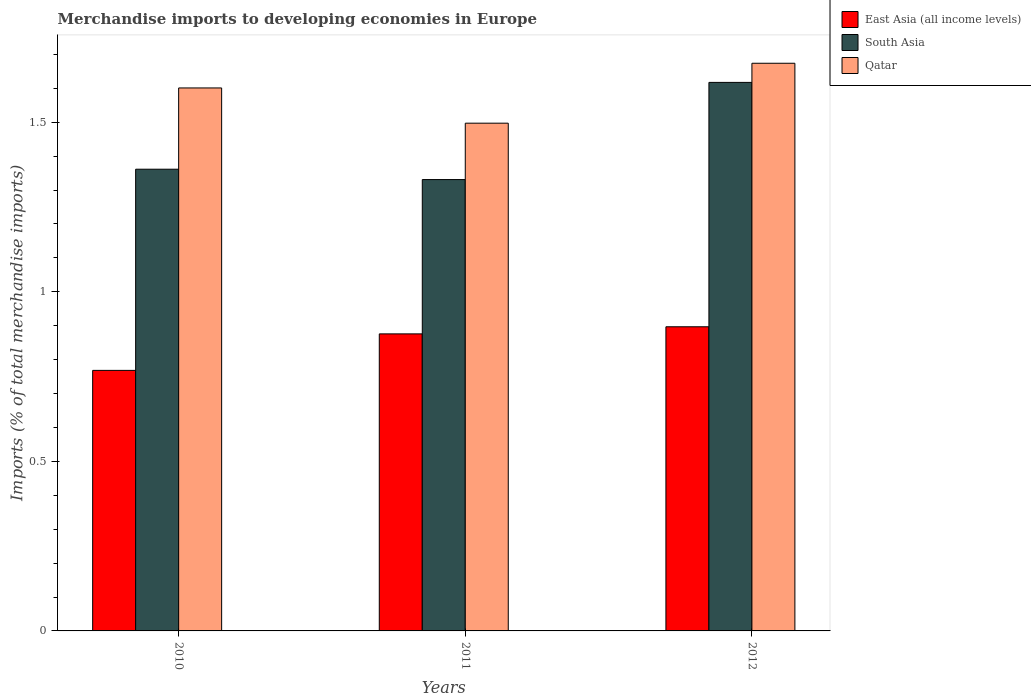How many different coloured bars are there?
Your answer should be compact. 3. Are the number of bars on each tick of the X-axis equal?
Your answer should be compact. Yes. How many bars are there on the 3rd tick from the right?
Provide a succinct answer. 3. What is the label of the 2nd group of bars from the left?
Offer a very short reply. 2011. What is the percentage total merchandise imports in East Asia (all income levels) in 2010?
Provide a short and direct response. 0.77. Across all years, what is the maximum percentage total merchandise imports in Qatar?
Make the answer very short. 1.67. Across all years, what is the minimum percentage total merchandise imports in Qatar?
Keep it short and to the point. 1.5. What is the total percentage total merchandise imports in Qatar in the graph?
Make the answer very short. 4.77. What is the difference between the percentage total merchandise imports in South Asia in 2011 and that in 2012?
Keep it short and to the point. -0.29. What is the difference between the percentage total merchandise imports in South Asia in 2011 and the percentage total merchandise imports in East Asia (all income levels) in 2012?
Make the answer very short. 0.43. What is the average percentage total merchandise imports in South Asia per year?
Make the answer very short. 1.44. In the year 2012, what is the difference between the percentage total merchandise imports in East Asia (all income levels) and percentage total merchandise imports in South Asia?
Make the answer very short. -0.72. What is the ratio of the percentage total merchandise imports in South Asia in 2010 to that in 2012?
Offer a terse response. 0.84. What is the difference between the highest and the second highest percentage total merchandise imports in Qatar?
Your response must be concise. 0.07. What is the difference between the highest and the lowest percentage total merchandise imports in South Asia?
Offer a terse response. 0.29. What does the 3rd bar from the left in 2010 represents?
Ensure brevity in your answer.  Qatar. Are the values on the major ticks of Y-axis written in scientific E-notation?
Give a very brief answer. No. Does the graph contain any zero values?
Your answer should be compact. No. Where does the legend appear in the graph?
Keep it short and to the point. Top right. How are the legend labels stacked?
Offer a very short reply. Vertical. What is the title of the graph?
Offer a very short reply. Merchandise imports to developing economies in Europe. Does "Lower middle income" appear as one of the legend labels in the graph?
Provide a short and direct response. No. What is the label or title of the X-axis?
Keep it short and to the point. Years. What is the label or title of the Y-axis?
Your response must be concise. Imports (% of total merchandise imports). What is the Imports (% of total merchandise imports) of East Asia (all income levels) in 2010?
Offer a very short reply. 0.77. What is the Imports (% of total merchandise imports) of South Asia in 2010?
Offer a terse response. 1.36. What is the Imports (% of total merchandise imports) in Qatar in 2010?
Provide a succinct answer. 1.6. What is the Imports (% of total merchandise imports) of East Asia (all income levels) in 2011?
Your response must be concise. 0.88. What is the Imports (% of total merchandise imports) in South Asia in 2011?
Offer a terse response. 1.33. What is the Imports (% of total merchandise imports) of Qatar in 2011?
Your response must be concise. 1.5. What is the Imports (% of total merchandise imports) in East Asia (all income levels) in 2012?
Offer a very short reply. 0.9. What is the Imports (% of total merchandise imports) in South Asia in 2012?
Keep it short and to the point. 1.62. What is the Imports (% of total merchandise imports) in Qatar in 2012?
Give a very brief answer. 1.67. Across all years, what is the maximum Imports (% of total merchandise imports) in East Asia (all income levels)?
Give a very brief answer. 0.9. Across all years, what is the maximum Imports (% of total merchandise imports) of South Asia?
Provide a short and direct response. 1.62. Across all years, what is the maximum Imports (% of total merchandise imports) in Qatar?
Provide a short and direct response. 1.67. Across all years, what is the minimum Imports (% of total merchandise imports) in East Asia (all income levels)?
Offer a very short reply. 0.77. Across all years, what is the minimum Imports (% of total merchandise imports) in South Asia?
Give a very brief answer. 1.33. Across all years, what is the minimum Imports (% of total merchandise imports) of Qatar?
Ensure brevity in your answer.  1.5. What is the total Imports (% of total merchandise imports) in East Asia (all income levels) in the graph?
Your answer should be very brief. 2.54. What is the total Imports (% of total merchandise imports) in South Asia in the graph?
Provide a short and direct response. 4.31. What is the total Imports (% of total merchandise imports) of Qatar in the graph?
Make the answer very short. 4.77. What is the difference between the Imports (% of total merchandise imports) of East Asia (all income levels) in 2010 and that in 2011?
Offer a very short reply. -0.11. What is the difference between the Imports (% of total merchandise imports) in South Asia in 2010 and that in 2011?
Make the answer very short. 0.03. What is the difference between the Imports (% of total merchandise imports) of Qatar in 2010 and that in 2011?
Offer a terse response. 0.1. What is the difference between the Imports (% of total merchandise imports) of East Asia (all income levels) in 2010 and that in 2012?
Your response must be concise. -0.13. What is the difference between the Imports (% of total merchandise imports) in South Asia in 2010 and that in 2012?
Your response must be concise. -0.26. What is the difference between the Imports (% of total merchandise imports) in Qatar in 2010 and that in 2012?
Offer a very short reply. -0.07. What is the difference between the Imports (% of total merchandise imports) of East Asia (all income levels) in 2011 and that in 2012?
Give a very brief answer. -0.02. What is the difference between the Imports (% of total merchandise imports) in South Asia in 2011 and that in 2012?
Your answer should be very brief. -0.29. What is the difference between the Imports (% of total merchandise imports) of Qatar in 2011 and that in 2012?
Ensure brevity in your answer.  -0.18. What is the difference between the Imports (% of total merchandise imports) of East Asia (all income levels) in 2010 and the Imports (% of total merchandise imports) of South Asia in 2011?
Offer a terse response. -0.56. What is the difference between the Imports (% of total merchandise imports) of East Asia (all income levels) in 2010 and the Imports (% of total merchandise imports) of Qatar in 2011?
Offer a terse response. -0.73. What is the difference between the Imports (% of total merchandise imports) of South Asia in 2010 and the Imports (% of total merchandise imports) of Qatar in 2011?
Give a very brief answer. -0.14. What is the difference between the Imports (% of total merchandise imports) in East Asia (all income levels) in 2010 and the Imports (% of total merchandise imports) in South Asia in 2012?
Offer a terse response. -0.85. What is the difference between the Imports (% of total merchandise imports) in East Asia (all income levels) in 2010 and the Imports (% of total merchandise imports) in Qatar in 2012?
Ensure brevity in your answer.  -0.91. What is the difference between the Imports (% of total merchandise imports) in South Asia in 2010 and the Imports (% of total merchandise imports) in Qatar in 2012?
Provide a short and direct response. -0.31. What is the difference between the Imports (% of total merchandise imports) of East Asia (all income levels) in 2011 and the Imports (% of total merchandise imports) of South Asia in 2012?
Your answer should be very brief. -0.74. What is the difference between the Imports (% of total merchandise imports) in East Asia (all income levels) in 2011 and the Imports (% of total merchandise imports) in Qatar in 2012?
Your answer should be compact. -0.8. What is the difference between the Imports (% of total merchandise imports) in South Asia in 2011 and the Imports (% of total merchandise imports) in Qatar in 2012?
Your answer should be compact. -0.34. What is the average Imports (% of total merchandise imports) in East Asia (all income levels) per year?
Make the answer very short. 0.85. What is the average Imports (% of total merchandise imports) of South Asia per year?
Provide a short and direct response. 1.44. What is the average Imports (% of total merchandise imports) in Qatar per year?
Provide a succinct answer. 1.59. In the year 2010, what is the difference between the Imports (% of total merchandise imports) of East Asia (all income levels) and Imports (% of total merchandise imports) of South Asia?
Your response must be concise. -0.59. In the year 2010, what is the difference between the Imports (% of total merchandise imports) of East Asia (all income levels) and Imports (% of total merchandise imports) of Qatar?
Your answer should be compact. -0.83. In the year 2010, what is the difference between the Imports (% of total merchandise imports) of South Asia and Imports (% of total merchandise imports) of Qatar?
Offer a terse response. -0.24. In the year 2011, what is the difference between the Imports (% of total merchandise imports) in East Asia (all income levels) and Imports (% of total merchandise imports) in South Asia?
Provide a short and direct response. -0.46. In the year 2011, what is the difference between the Imports (% of total merchandise imports) of East Asia (all income levels) and Imports (% of total merchandise imports) of Qatar?
Offer a terse response. -0.62. In the year 2011, what is the difference between the Imports (% of total merchandise imports) of South Asia and Imports (% of total merchandise imports) of Qatar?
Provide a short and direct response. -0.17. In the year 2012, what is the difference between the Imports (% of total merchandise imports) of East Asia (all income levels) and Imports (% of total merchandise imports) of South Asia?
Provide a short and direct response. -0.72. In the year 2012, what is the difference between the Imports (% of total merchandise imports) in East Asia (all income levels) and Imports (% of total merchandise imports) in Qatar?
Provide a succinct answer. -0.78. In the year 2012, what is the difference between the Imports (% of total merchandise imports) in South Asia and Imports (% of total merchandise imports) in Qatar?
Offer a terse response. -0.06. What is the ratio of the Imports (% of total merchandise imports) in East Asia (all income levels) in 2010 to that in 2011?
Your answer should be compact. 0.88. What is the ratio of the Imports (% of total merchandise imports) of Qatar in 2010 to that in 2011?
Provide a succinct answer. 1.07. What is the ratio of the Imports (% of total merchandise imports) of East Asia (all income levels) in 2010 to that in 2012?
Give a very brief answer. 0.86. What is the ratio of the Imports (% of total merchandise imports) in South Asia in 2010 to that in 2012?
Offer a very short reply. 0.84. What is the ratio of the Imports (% of total merchandise imports) in Qatar in 2010 to that in 2012?
Provide a succinct answer. 0.96. What is the ratio of the Imports (% of total merchandise imports) in East Asia (all income levels) in 2011 to that in 2012?
Your answer should be very brief. 0.98. What is the ratio of the Imports (% of total merchandise imports) in South Asia in 2011 to that in 2012?
Your answer should be compact. 0.82. What is the ratio of the Imports (% of total merchandise imports) in Qatar in 2011 to that in 2012?
Ensure brevity in your answer.  0.89. What is the difference between the highest and the second highest Imports (% of total merchandise imports) in East Asia (all income levels)?
Make the answer very short. 0.02. What is the difference between the highest and the second highest Imports (% of total merchandise imports) of South Asia?
Your response must be concise. 0.26. What is the difference between the highest and the second highest Imports (% of total merchandise imports) in Qatar?
Offer a very short reply. 0.07. What is the difference between the highest and the lowest Imports (% of total merchandise imports) of East Asia (all income levels)?
Your answer should be compact. 0.13. What is the difference between the highest and the lowest Imports (% of total merchandise imports) of South Asia?
Offer a terse response. 0.29. What is the difference between the highest and the lowest Imports (% of total merchandise imports) in Qatar?
Your response must be concise. 0.18. 